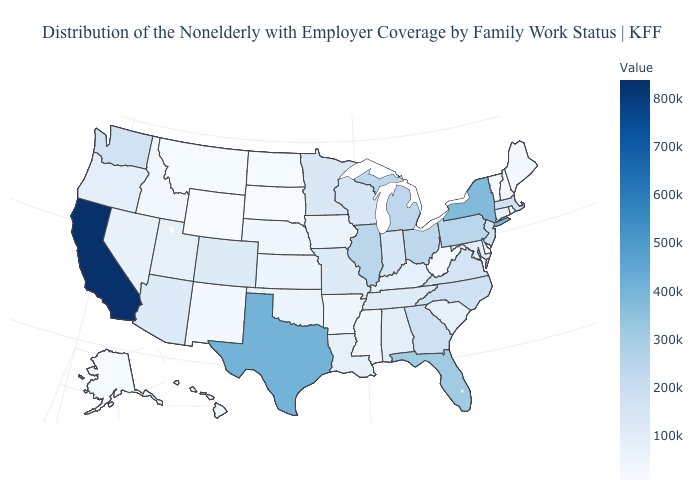Does the map have missing data?
Concise answer only. No. Which states hav the highest value in the South?
Quick response, please. Texas. Which states hav the highest value in the West?
Answer briefly. California. Which states hav the highest value in the MidWest?
Be succinct. Illinois. Does Louisiana have a higher value than Texas?
Give a very brief answer. No. Among the states that border New York , does Vermont have the lowest value?
Short answer required. Yes. Which states have the lowest value in the USA?
Write a very short answer. Wyoming. Does Montana have the highest value in the USA?
Short answer required. No. Which states have the highest value in the USA?
Keep it brief. California. 